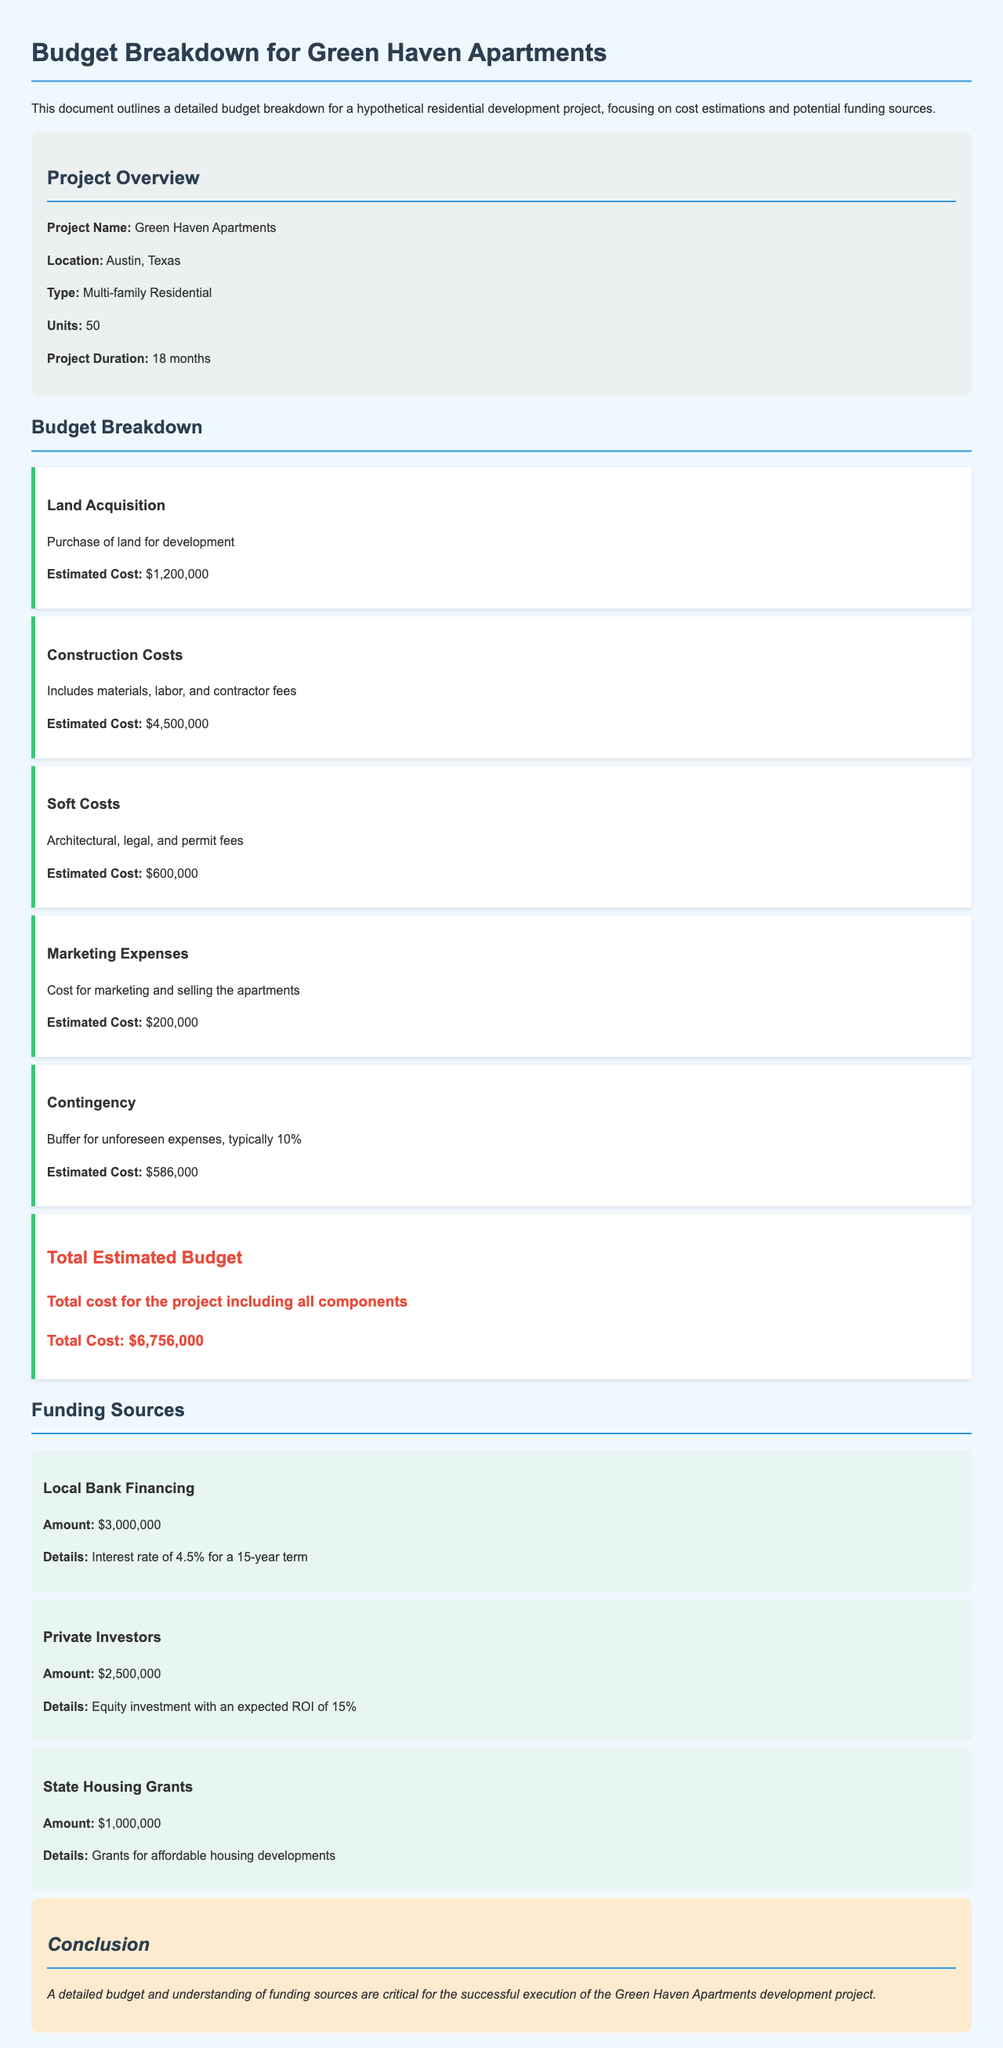What is the project name? The project name is stated in the document as Green Haven Apartments.
Answer: Green Haven Apartments What is the location of the project? The location of the project is specified in the document as Austin, Texas.
Answer: Austin, Texas What is the estimated cost for construction? The estimated cost for construction is detailed in the document as $4,500,000.
Answer: $4,500,000 How many units are there in the project? The number of units in the project is mentioned as 50.
Answer: 50 What percentage does the contingency represent? The contingency is described as typically 10% in the document.
Answer: 10% What is the total estimated budget? The total estimated budget is provided in the document, which sums up all costs.
Answer: $6,756,000 What amount is allocated for state housing grants? The document lists the amount for state housing grants as $1,000,000.
Answer: $1,000,000 What is the interest rate for local bank financing? The interest rate for local bank financing is noted as 4.5%.
Answer: 4.5% What type of project is Green Haven Apartments? The project type is classified in the document as Multi-family Residential.
Answer: Multi-family Residential 